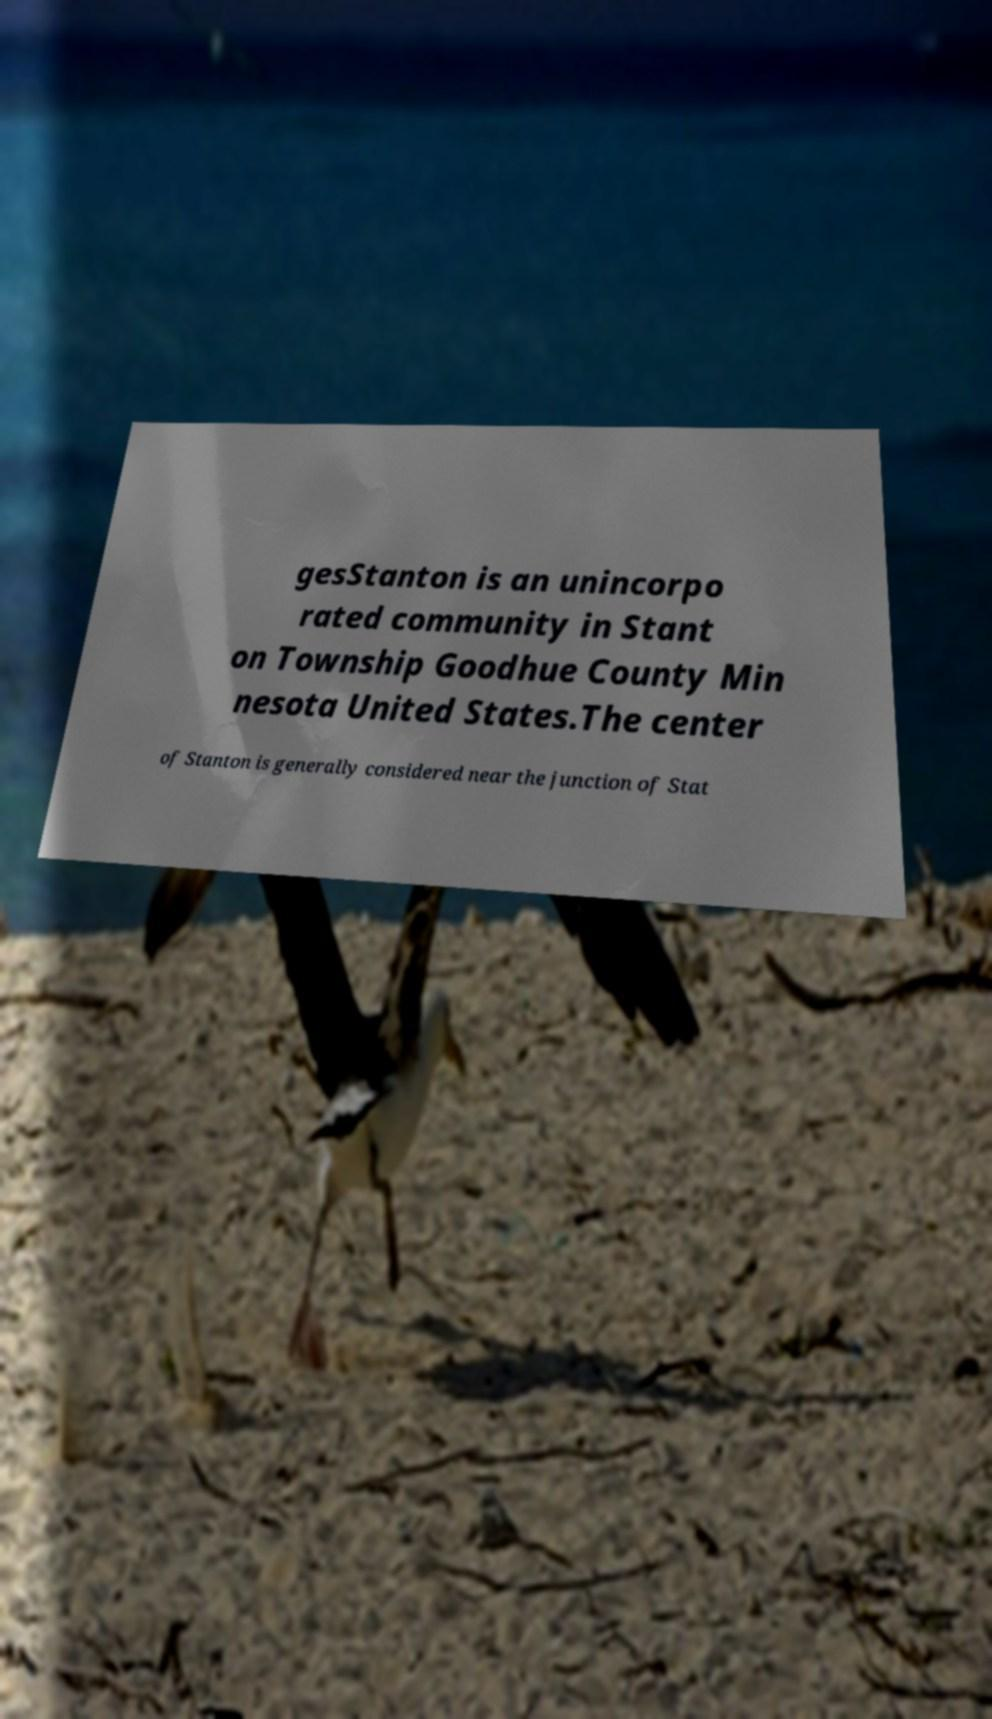There's text embedded in this image that I need extracted. Can you transcribe it verbatim? gesStanton is an unincorpo rated community in Stant on Township Goodhue County Min nesota United States.The center of Stanton is generally considered near the junction of Stat 